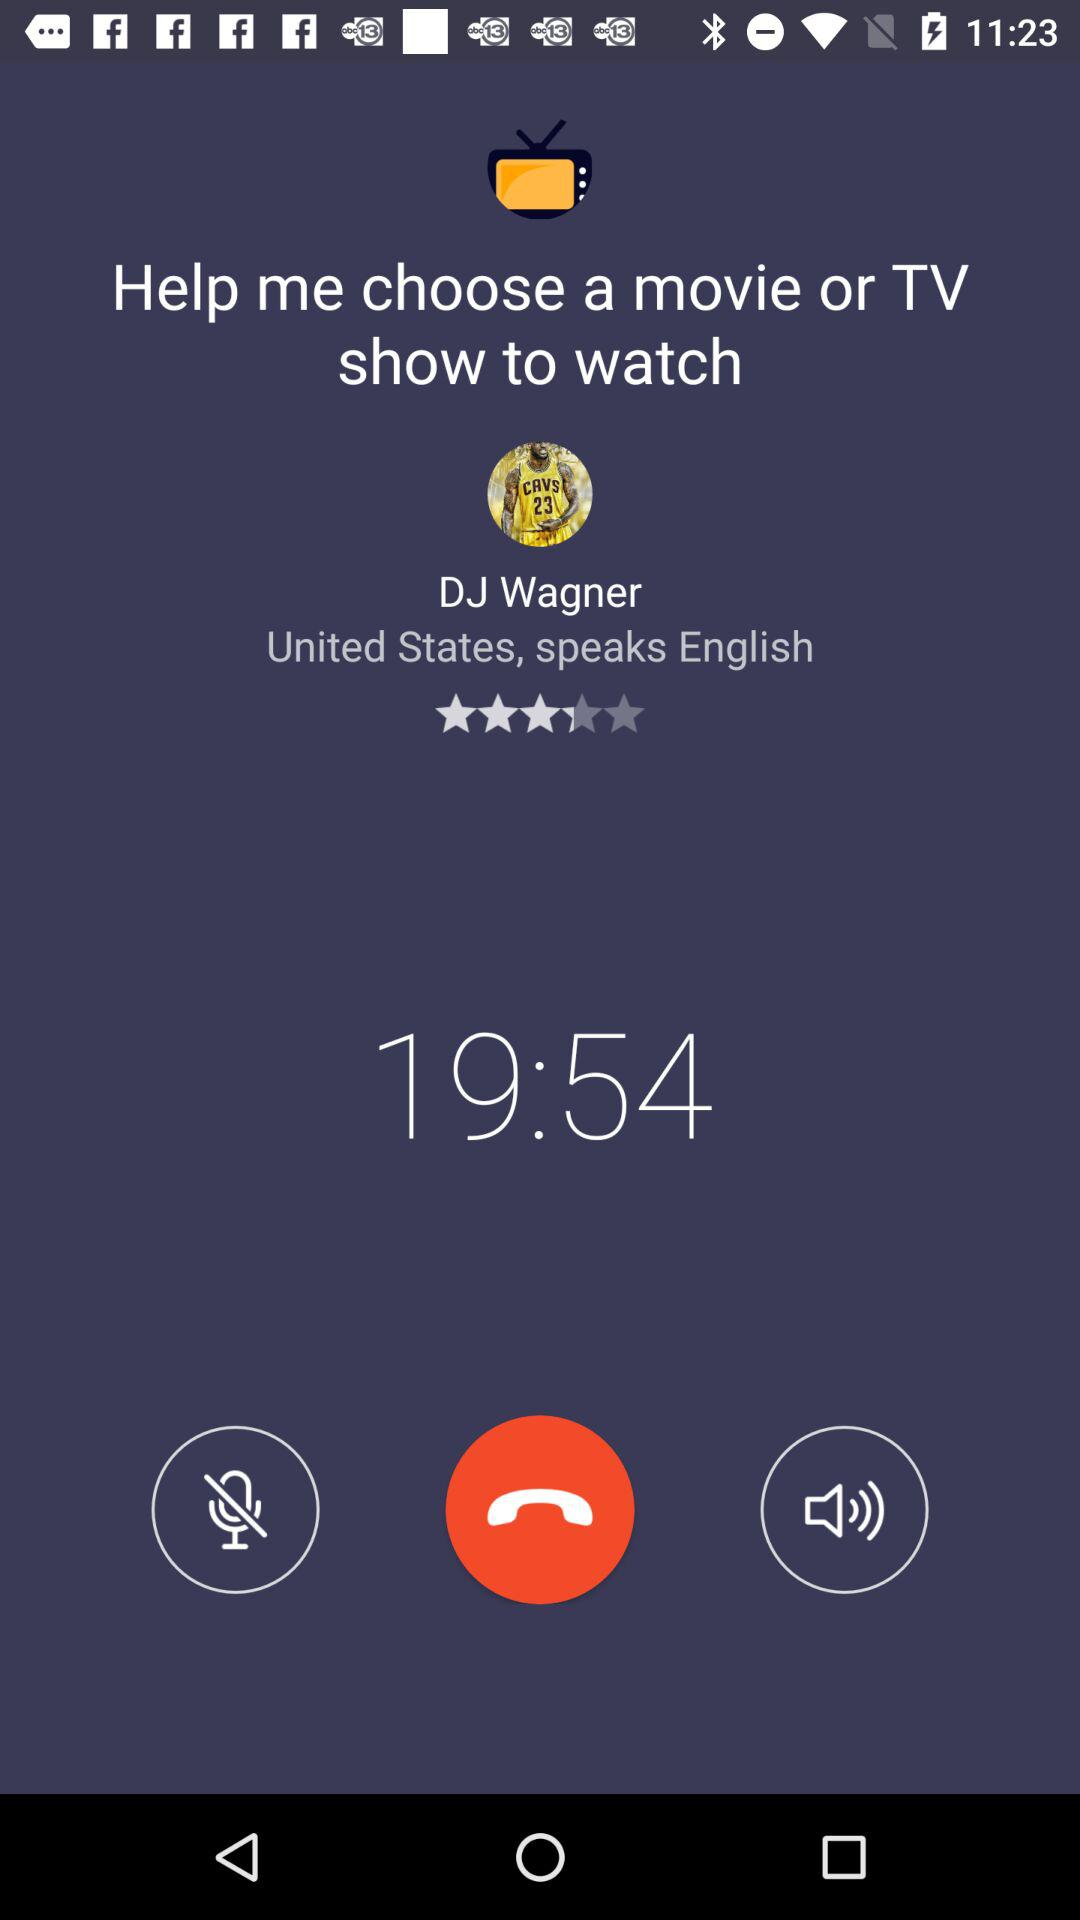What is the name of the person who is calling? The name of the person is DJ Wagner. 